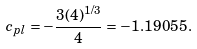<formula> <loc_0><loc_0><loc_500><loc_500>c _ { p l } = - \frac { 3 ( 4 ) ^ { 1 / 3 } } { 4 } = - 1 . 1 9 0 5 5 .</formula> 